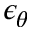Convert formula to latex. <formula><loc_0><loc_0><loc_500><loc_500>\epsilon _ { \theta }</formula> 